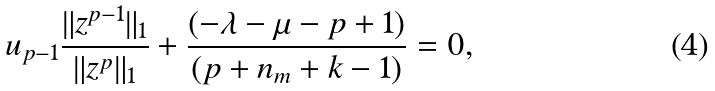Convert formula to latex. <formula><loc_0><loc_0><loc_500><loc_500>u _ { p - 1 } \frac { \| z ^ { p - 1 } \| _ { 1 } } { \| z ^ { p } \| _ { 1 } } + \frac { ( - \lambda - \mu - p + 1 ) } { ( p + n _ { m } + k - 1 ) } = 0 ,</formula> 